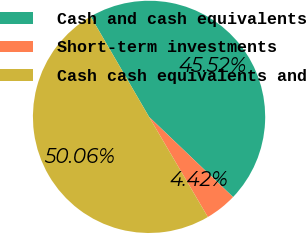<chart> <loc_0><loc_0><loc_500><loc_500><pie_chart><fcel>Cash and cash equivalents<fcel>Short-term investments<fcel>Cash cash equivalents and<nl><fcel>45.52%<fcel>4.42%<fcel>50.07%<nl></chart> 